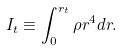<formula> <loc_0><loc_0><loc_500><loc_500>I _ { t } \equiv \int _ { 0 } ^ { r _ { t } } \rho r ^ { 4 } d r .</formula> 